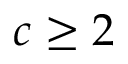Convert formula to latex. <formula><loc_0><loc_0><loc_500><loc_500>c \geq 2</formula> 